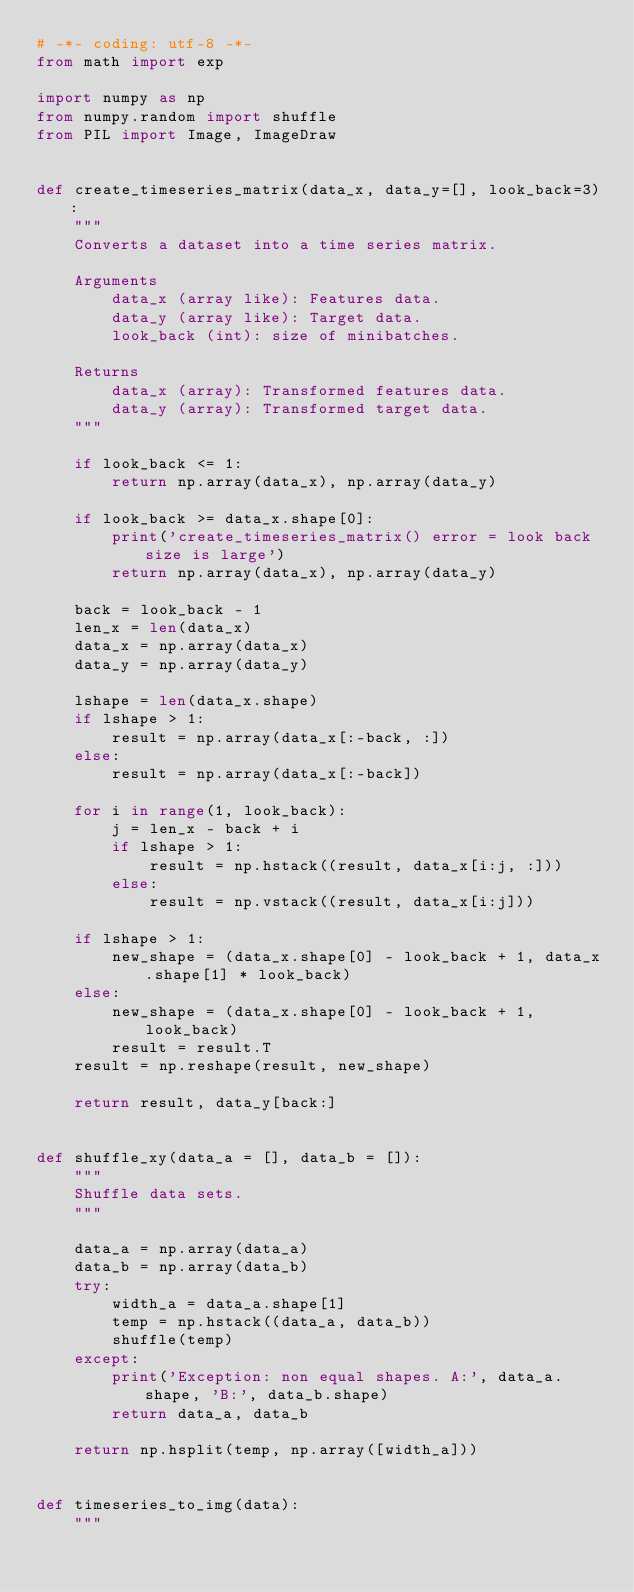Convert code to text. <code><loc_0><loc_0><loc_500><loc_500><_Python_># -*- coding: utf-8 -*-
from math import exp

import numpy as np
from numpy.random import shuffle
from PIL import Image, ImageDraw


def create_timeseries_matrix(data_x, data_y=[], look_back=3):
    """
    Converts a dataset into a time series matrix.
    
    Arguments
        data_x (array like): Features data.
        data_y (array like): Target data.
        look_back (int): size of minibatches.
        
    Returns
        data_x (array): Transformed features data.
        data_y (array): Transformed target data.
    """

    if look_back <= 1:
        return np.array(data_x), np.array(data_y)

    if look_back >= data_x.shape[0]:
        print('create_timeseries_matrix() error = look back size is large')
        return np.array(data_x), np.array(data_y)

    back = look_back - 1
    len_x = len(data_x)
    data_x = np.array(data_x)
    data_y = np.array(data_y)

    lshape = len(data_x.shape)
    if lshape > 1:
        result = np.array(data_x[:-back, :])
    else:
        result = np.array(data_x[:-back])

    for i in range(1, look_back):
        j = len_x - back + i
        if lshape > 1:
            result = np.hstack((result, data_x[i:j, :]))
        else:
            result = np.vstack((result, data_x[i:j]))

    if lshape > 1:
        new_shape = (data_x.shape[0] - look_back + 1, data_x.shape[1] * look_back)
    else:
        new_shape = (data_x.shape[0] - look_back + 1, look_back)
        result = result.T
    result = np.reshape(result, new_shape)

    return result, data_y[back:]


def shuffle_xy(data_a = [], data_b = []):
    """
    Shuffle data sets.
    """

    data_a = np.array(data_a)
    data_b = np.array(data_b)
    try:
        width_a = data_a.shape[1]
        temp = np.hstack((data_a, data_b))
        shuffle(temp)
    except:
        print('Exception: non equal shapes. A:', data_a.shape, 'B:', data_b.shape)
        return data_a, data_b
        
    return np.hsplit(temp, np.array([width_a]))


def timeseries_to_img(data):
    """</code> 